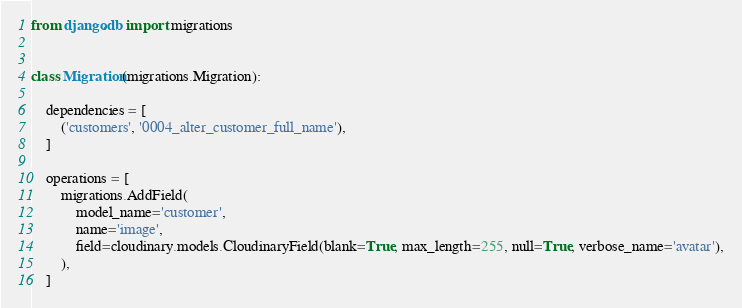Convert code to text. <code><loc_0><loc_0><loc_500><loc_500><_Python_>from django.db import migrations


class Migration(migrations.Migration):

    dependencies = [
        ('customers', '0004_alter_customer_full_name'),
    ]

    operations = [
        migrations.AddField(
            model_name='customer',
            name='image',
            field=cloudinary.models.CloudinaryField(blank=True, max_length=255, null=True, verbose_name='avatar'),
        ),
    ]
</code> 